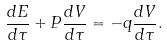<formula> <loc_0><loc_0><loc_500><loc_500>\frac { d E } { d \tau } + P \frac { d V } { d \tau } = - q \frac { d V } { d \tau } .</formula> 